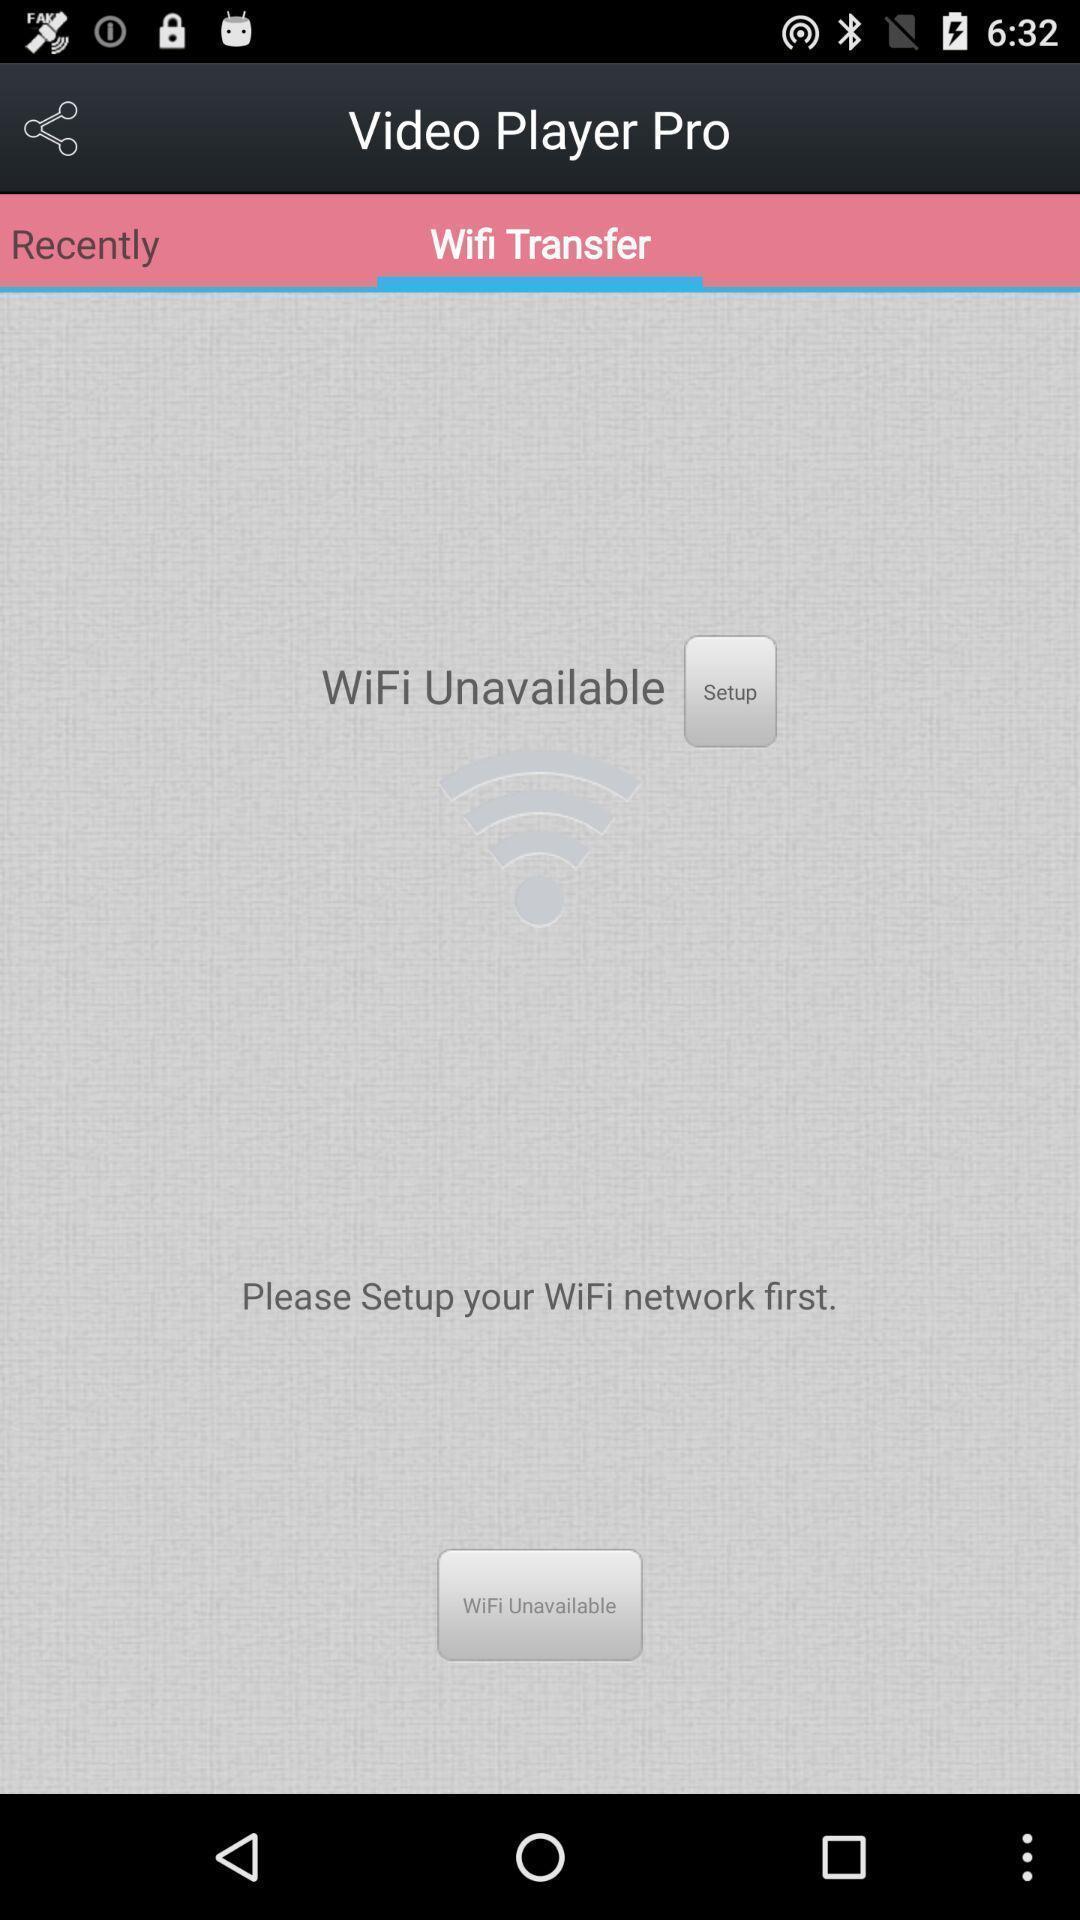What details can you identify in this image? Screen showing to set up wi-fi network option. 